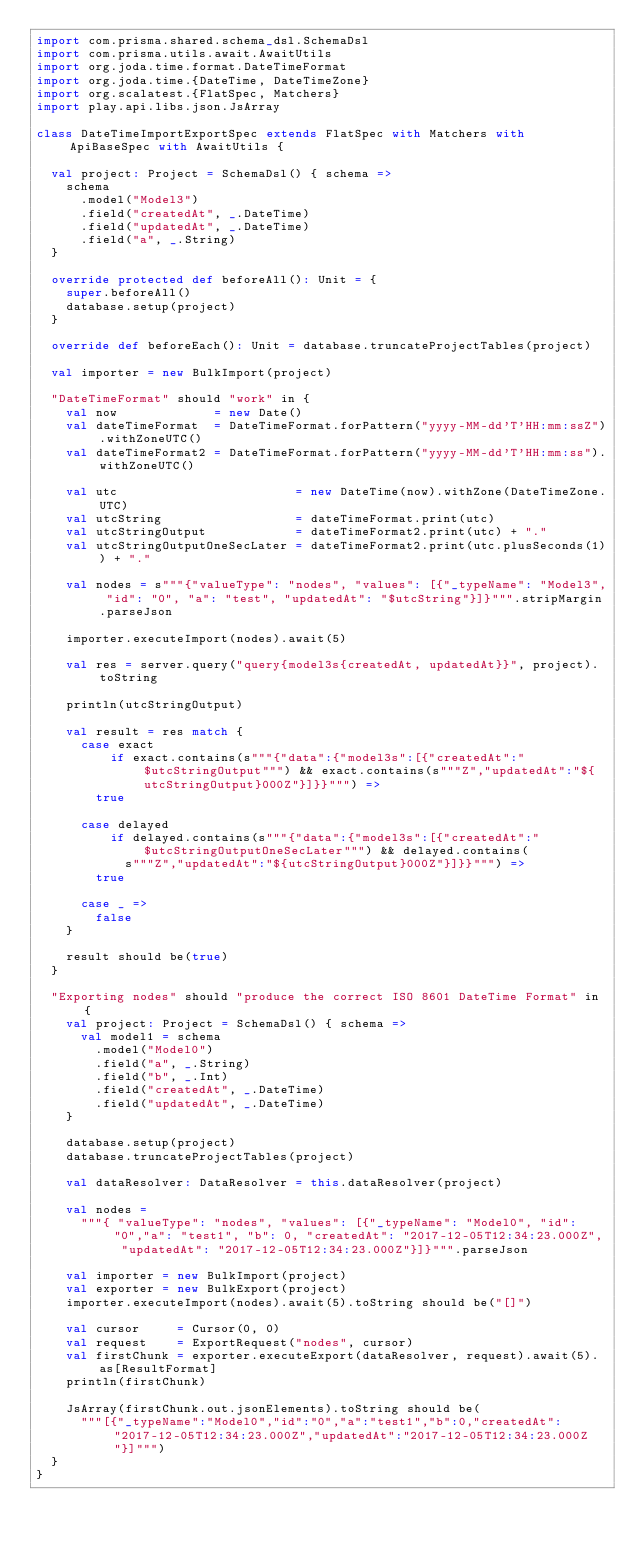<code> <loc_0><loc_0><loc_500><loc_500><_Scala_>import com.prisma.shared.schema_dsl.SchemaDsl
import com.prisma.utils.await.AwaitUtils
import org.joda.time.format.DateTimeFormat
import org.joda.time.{DateTime, DateTimeZone}
import org.scalatest.{FlatSpec, Matchers}
import play.api.libs.json.JsArray

class DateTimeImportExportSpec extends FlatSpec with Matchers with ApiBaseSpec with AwaitUtils {

  val project: Project = SchemaDsl() { schema =>
    schema
      .model("Model3")
      .field("createdAt", _.DateTime)
      .field("updatedAt", _.DateTime)
      .field("a", _.String)
  }

  override protected def beforeAll(): Unit = {
    super.beforeAll()
    database.setup(project)
  }

  override def beforeEach(): Unit = database.truncateProjectTables(project)

  val importer = new BulkImport(project)

  "DateTimeFormat" should "work" in {
    val now             = new Date()
    val dateTimeFormat  = DateTimeFormat.forPattern("yyyy-MM-dd'T'HH:mm:ssZ").withZoneUTC()
    val dateTimeFormat2 = DateTimeFormat.forPattern("yyyy-MM-dd'T'HH:mm:ss").withZoneUTC()

    val utc                        = new DateTime(now).withZone(DateTimeZone.UTC)
    val utcString                  = dateTimeFormat.print(utc)
    val utcStringOutput            = dateTimeFormat2.print(utc) + "."
    val utcStringOutputOneSecLater = dateTimeFormat2.print(utc.plusSeconds(1)) + "."

    val nodes = s"""{"valueType": "nodes", "values": [{"_typeName": "Model3", "id": "0", "a": "test", "updatedAt": "$utcString"}]}""".stripMargin.parseJson

    importer.executeImport(nodes).await(5)

    val res = server.query("query{model3s{createdAt, updatedAt}}", project).toString

    println(utcStringOutput)

    val result = res match {
      case exact
          if exact.contains(s"""{"data":{"model3s":[{"createdAt":"$utcStringOutput""") && exact.contains(s"""Z","updatedAt":"${utcStringOutput}000Z"}]}}""") =>
        true

      case delayed
          if delayed.contains(s"""{"data":{"model3s":[{"createdAt":"$utcStringOutputOneSecLater""") && delayed.contains(
            s"""Z","updatedAt":"${utcStringOutput}000Z"}]}}""") =>
        true

      case _ =>
        false
    }

    result should be(true)
  }

  "Exporting nodes" should "produce the correct ISO 8601 DateTime Format" in {
    val project: Project = SchemaDsl() { schema =>
      val model1 = schema
        .model("Model0")
        .field("a", _.String)
        .field("b", _.Int)
        .field("createdAt", _.DateTime)
        .field("updatedAt", _.DateTime)
    }

    database.setup(project)
    database.truncateProjectTables(project)

    val dataResolver: DataResolver = this.dataResolver(project)

    val nodes =
      """{ "valueType": "nodes", "values": [{"_typeName": "Model0", "id": "0","a": "test1", "b": 0, "createdAt": "2017-12-05T12:34:23.000Z", "updatedAt": "2017-12-05T12:34:23.000Z"}]}""".parseJson

    val importer = new BulkImport(project)
    val exporter = new BulkExport(project)
    importer.executeImport(nodes).await(5).toString should be("[]")

    val cursor     = Cursor(0, 0)
    val request    = ExportRequest("nodes", cursor)
    val firstChunk = exporter.executeExport(dataResolver, request).await(5).as[ResultFormat]
    println(firstChunk)

    JsArray(firstChunk.out.jsonElements).toString should be(
      """[{"_typeName":"Model0","id":"0","a":"test1","b":0,"createdAt":"2017-12-05T12:34:23.000Z","updatedAt":"2017-12-05T12:34:23.000Z"}]""")
  }
}
</code> 